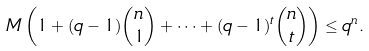Convert formula to latex. <formula><loc_0><loc_0><loc_500><loc_500>M \left ( 1 + ( q - 1 ) { n \choose 1 } + \cdots + ( q - 1 ) ^ { t } { n \choose t } \right ) \leq q ^ { n } .</formula> 